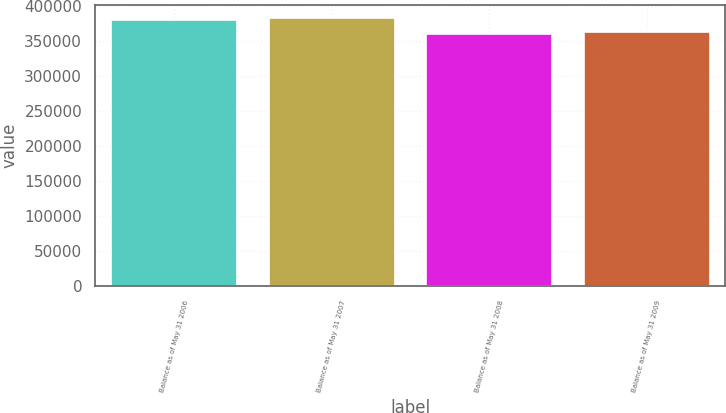Convert chart to OTSL. <chart><loc_0><loc_0><loc_500><loc_500><bar_chart><fcel>Balance as of May 31 2006<fcel>Balance as of May 31 2007<fcel>Balance as of May 31 2008<fcel>Balance as of May 31 2009<nl><fcel>380303<fcel>382468<fcel>360500<fcel>362665<nl></chart> 